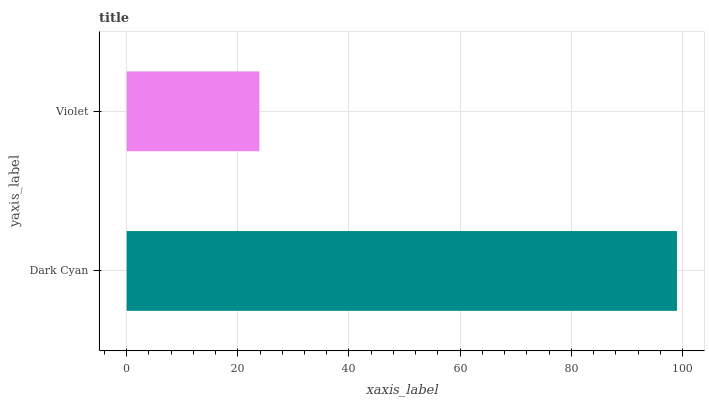Is Violet the minimum?
Answer yes or no. Yes. Is Dark Cyan the maximum?
Answer yes or no. Yes. Is Violet the maximum?
Answer yes or no. No. Is Dark Cyan greater than Violet?
Answer yes or no. Yes. Is Violet less than Dark Cyan?
Answer yes or no. Yes. Is Violet greater than Dark Cyan?
Answer yes or no. No. Is Dark Cyan less than Violet?
Answer yes or no. No. Is Dark Cyan the high median?
Answer yes or no. Yes. Is Violet the low median?
Answer yes or no. Yes. Is Violet the high median?
Answer yes or no. No. Is Dark Cyan the low median?
Answer yes or no. No. 